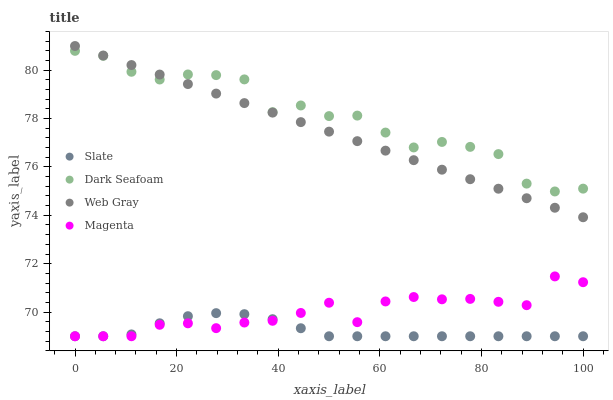Does Slate have the minimum area under the curve?
Answer yes or no. Yes. Does Dark Seafoam have the maximum area under the curve?
Answer yes or no. Yes. Does Web Gray have the minimum area under the curve?
Answer yes or no. No. Does Web Gray have the maximum area under the curve?
Answer yes or no. No. Is Web Gray the smoothest?
Answer yes or no. Yes. Is Dark Seafoam the roughest?
Answer yes or no. Yes. Is Dark Seafoam the smoothest?
Answer yes or no. No. Is Web Gray the roughest?
Answer yes or no. No. Does Slate have the lowest value?
Answer yes or no. Yes. Does Web Gray have the lowest value?
Answer yes or no. No. Does Web Gray have the highest value?
Answer yes or no. Yes. Does Dark Seafoam have the highest value?
Answer yes or no. No. Is Magenta less than Web Gray?
Answer yes or no. Yes. Is Web Gray greater than Magenta?
Answer yes or no. Yes. Does Slate intersect Magenta?
Answer yes or no. Yes. Is Slate less than Magenta?
Answer yes or no. No. Is Slate greater than Magenta?
Answer yes or no. No. Does Magenta intersect Web Gray?
Answer yes or no. No. 